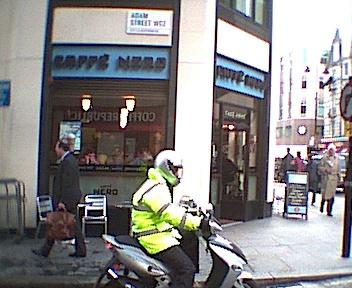How many helmets are being worn?
Answer briefly. 1. What store is in the picture?
Short answer required. Caffe nero. Is the rider using proper personal protective equipment?
Short answer required. Yes. 